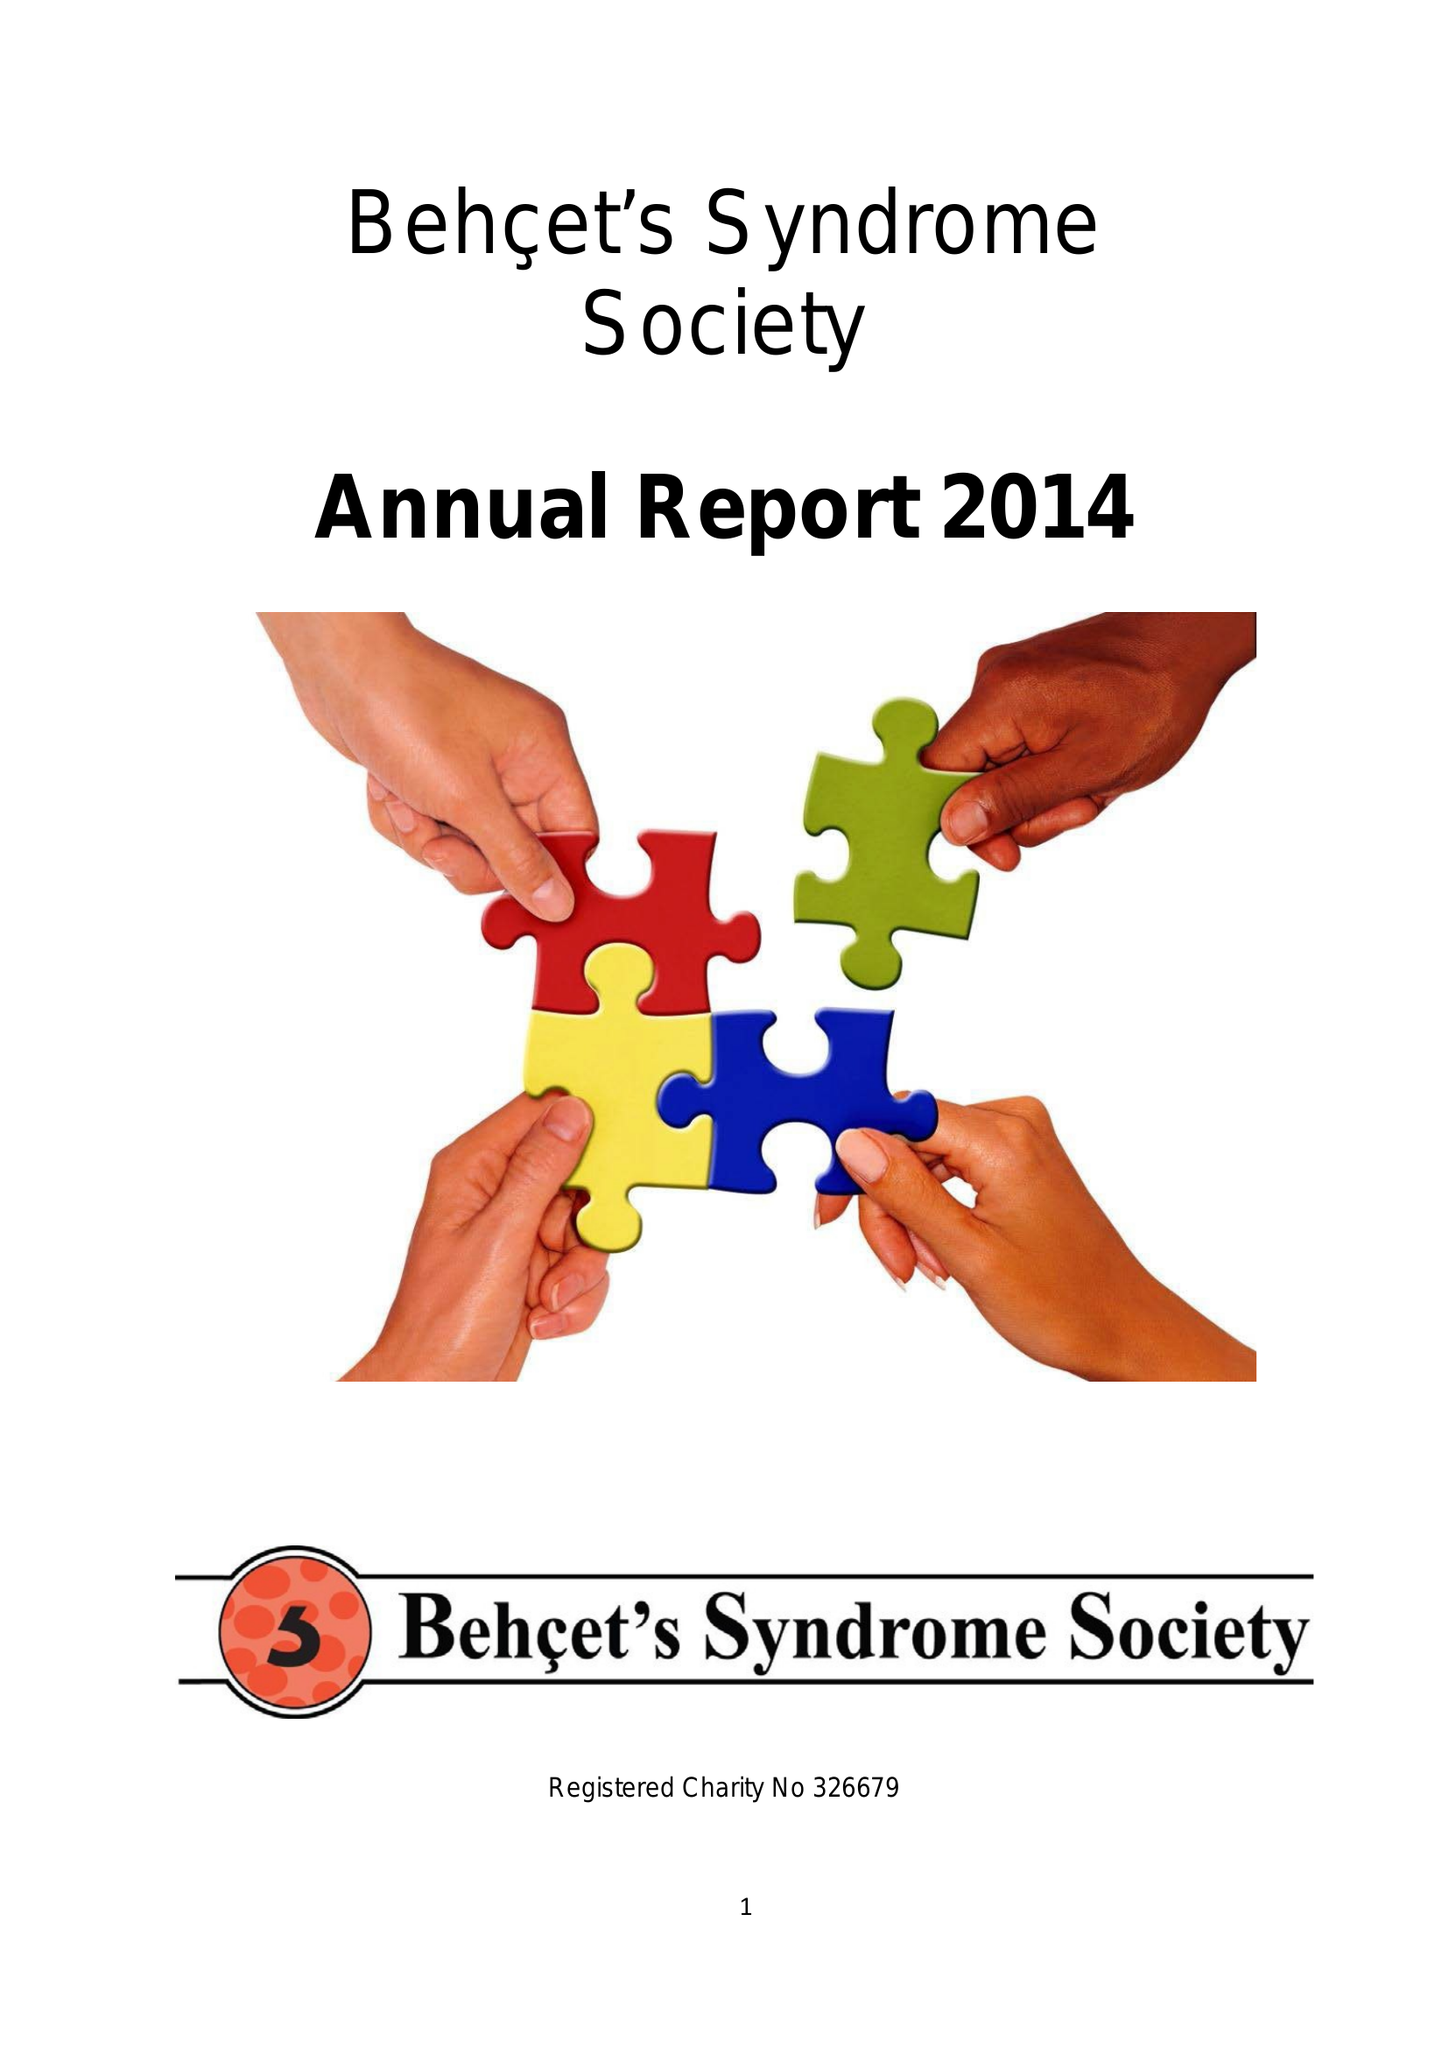What is the value for the charity_name?
Answer the question using a single word or phrase. Behcet's Uk 